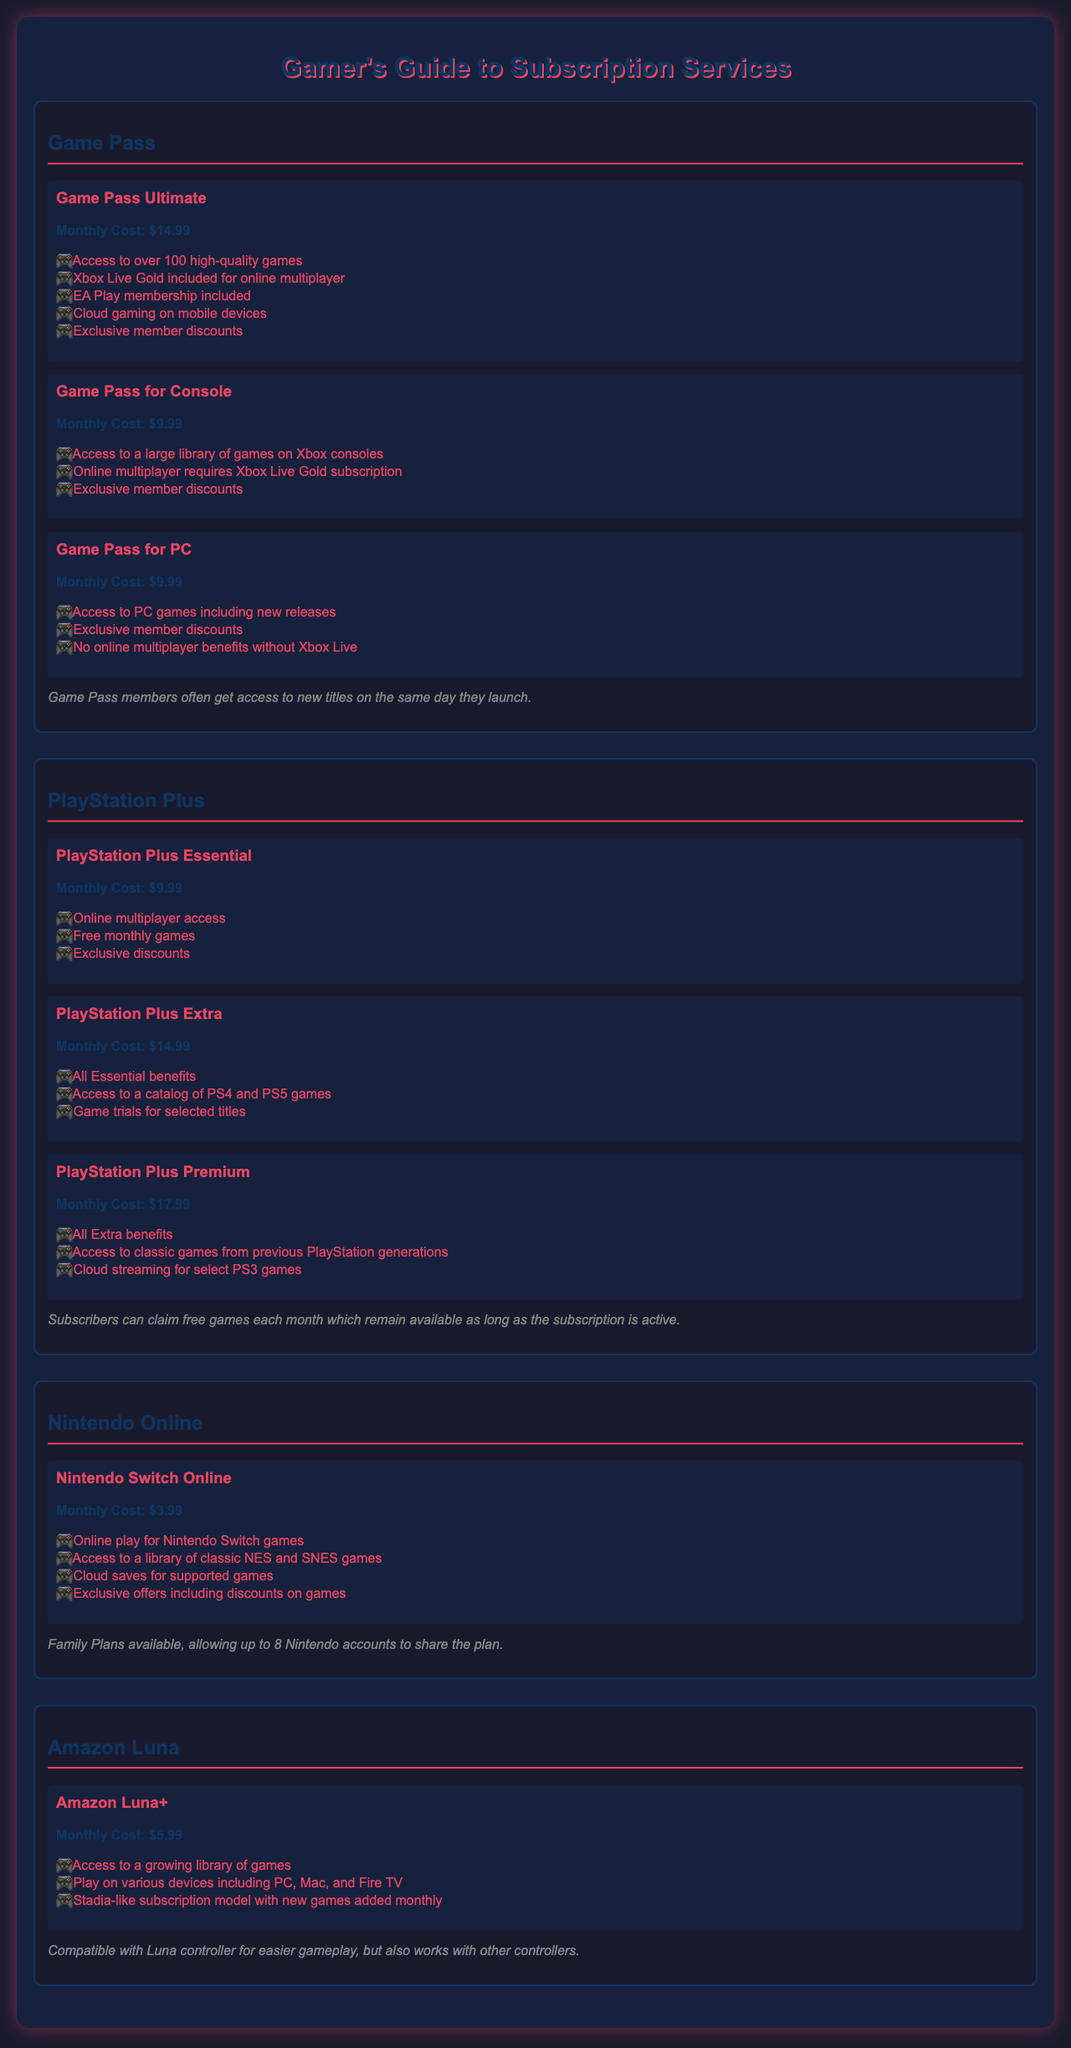What is the monthly cost of Game Pass Ultimate? The document states that the monthly cost of Game Pass Ultimate is $14.99.
Answer: $14.99 How many games do Game Pass members have access to? The document mentions that Game Pass members have access to over 100 high-quality games.
Answer: Over 100 What is included in PlayStation Plus Premium? The document lists that PlayStation Plus Premium includes access to classic games and cloud streaming for select PS3 games.
Answer: Access to classic games and cloud streaming for select PS3 games What is the price of Nintendo Switch Online? The document states that the monthly cost of Nintendo Switch Online is $3.99.
Answer: $3.99 What benefit is included with Game Pass for Console? The document shows that Game Pass for Console includes access to a large library of games on Xbox consoles.
Answer: Access to a large library of games on Xbox consoles How much more is PlayStation Plus Extra compared to Essential? The document indicates that PlayStation Plus Extra costs $14.99, while Essential costs $9.99, making a difference of $5.
Answer: $5 What is the cost for Amazon Luna+? According to the document, the monthly cost for Amazon Luna+ is $5.99.
Answer: $5.99 How many accounts can share a Nintendo Switch Online Family Plan? The document states that a Nintendo Switch Online Family Plan can allow up to 8 accounts.
Answer: Up to 8 accounts What type of gaming does Amazon Luna+ support? The document mentions that Amazon Luna+ supports gaming on various devices including PC, Mac, and Fire TV.
Answer: Various devices including PC, Mac, and Fire TV 